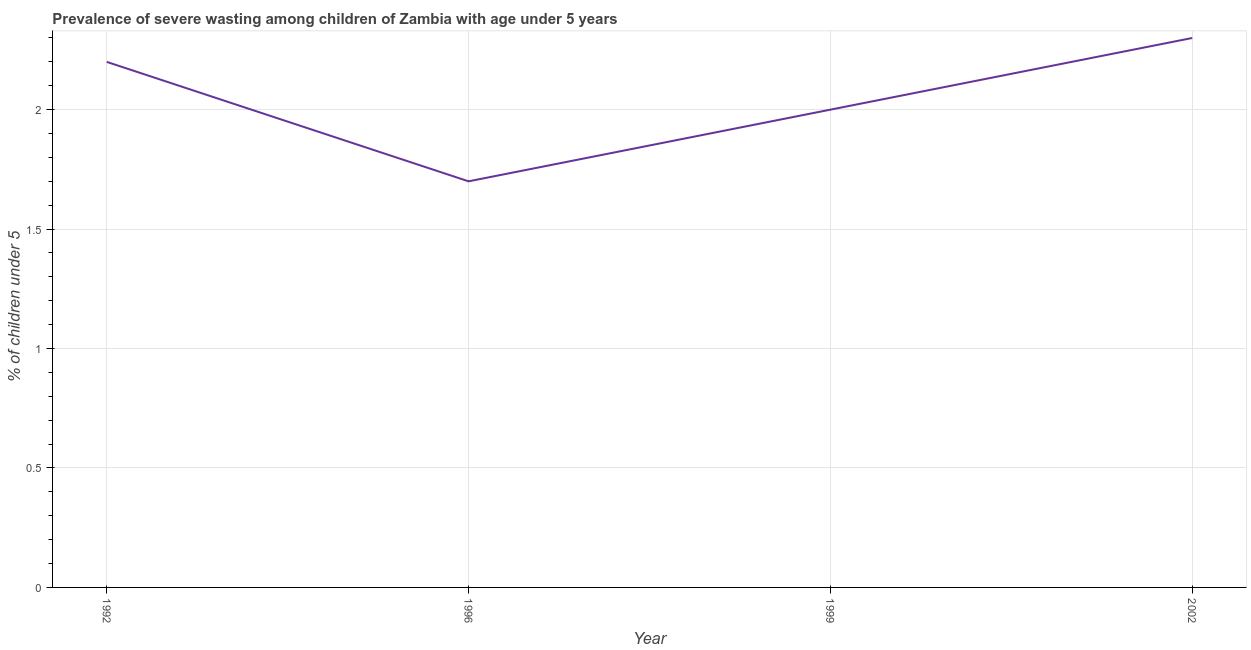What is the prevalence of severe wasting in 2002?
Your response must be concise. 2.3. Across all years, what is the maximum prevalence of severe wasting?
Your answer should be compact. 2.3. Across all years, what is the minimum prevalence of severe wasting?
Provide a succinct answer. 1.7. In which year was the prevalence of severe wasting maximum?
Provide a short and direct response. 2002. What is the sum of the prevalence of severe wasting?
Your response must be concise. 8.2. What is the difference between the prevalence of severe wasting in 1996 and 1999?
Ensure brevity in your answer.  -0.3. What is the average prevalence of severe wasting per year?
Make the answer very short. 2.05. What is the median prevalence of severe wasting?
Offer a terse response. 2.1. Do a majority of the years between 1999 and 1992 (inclusive) have prevalence of severe wasting greater than 1.3 %?
Your answer should be very brief. No. What is the ratio of the prevalence of severe wasting in 1996 to that in 1999?
Your answer should be compact. 0.85. What is the difference between the highest and the second highest prevalence of severe wasting?
Offer a terse response. 0.1. Is the sum of the prevalence of severe wasting in 1996 and 2002 greater than the maximum prevalence of severe wasting across all years?
Your response must be concise. Yes. What is the difference between the highest and the lowest prevalence of severe wasting?
Offer a very short reply. 0.6. In how many years, is the prevalence of severe wasting greater than the average prevalence of severe wasting taken over all years?
Provide a short and direct response. 2. Does the prevalence of severe wasting monotonically increase over the years?
Give a very brief answer. No. How many lines are there?
Make the answer very short. 1. Does the graph contain grids?
Keep it short and to the point. Yes. What is the title of the graph?
Provide a succinct answer. Prevalence of severe wasting among children of Zambia with age under 5 years. What is the label or title of the X-axis?
Provide a short and direct response. Year. What is the label or title of the Y-axis?
Ensure brevity in your answer.   % of children under 5. What is the  % of children under 5 of 1992?
Make the answer very short. 2.2. What is the  % of children under 5 in 1996?
Provide a short and direct response. 1.7. What is the  % of children under 5 in 1999?
Give a very brief answer. 2. What is the  % of children under 5 of 2002?
Your answer should be compact. 2.3. What is the difference between the  % of children under 5 in 1992 and 2002?
Provide a succinct answer. -0.1. What is the difference between the  % of children under 5 in 1996 and 2002?
Offer a terse response. -0.6. What is the ratio of the  % of children under 5 in 1992 to that in 1996?
Ensure brevity in your answer.  1.29. What is the ratio of the  % of children under 5 in 1996 to that in 2002?
Your response must be concise. 0.74. What is the ratio of the  % of children under 5 in 1999 to that in 2002?
Your answer should be compact. 0.87. 